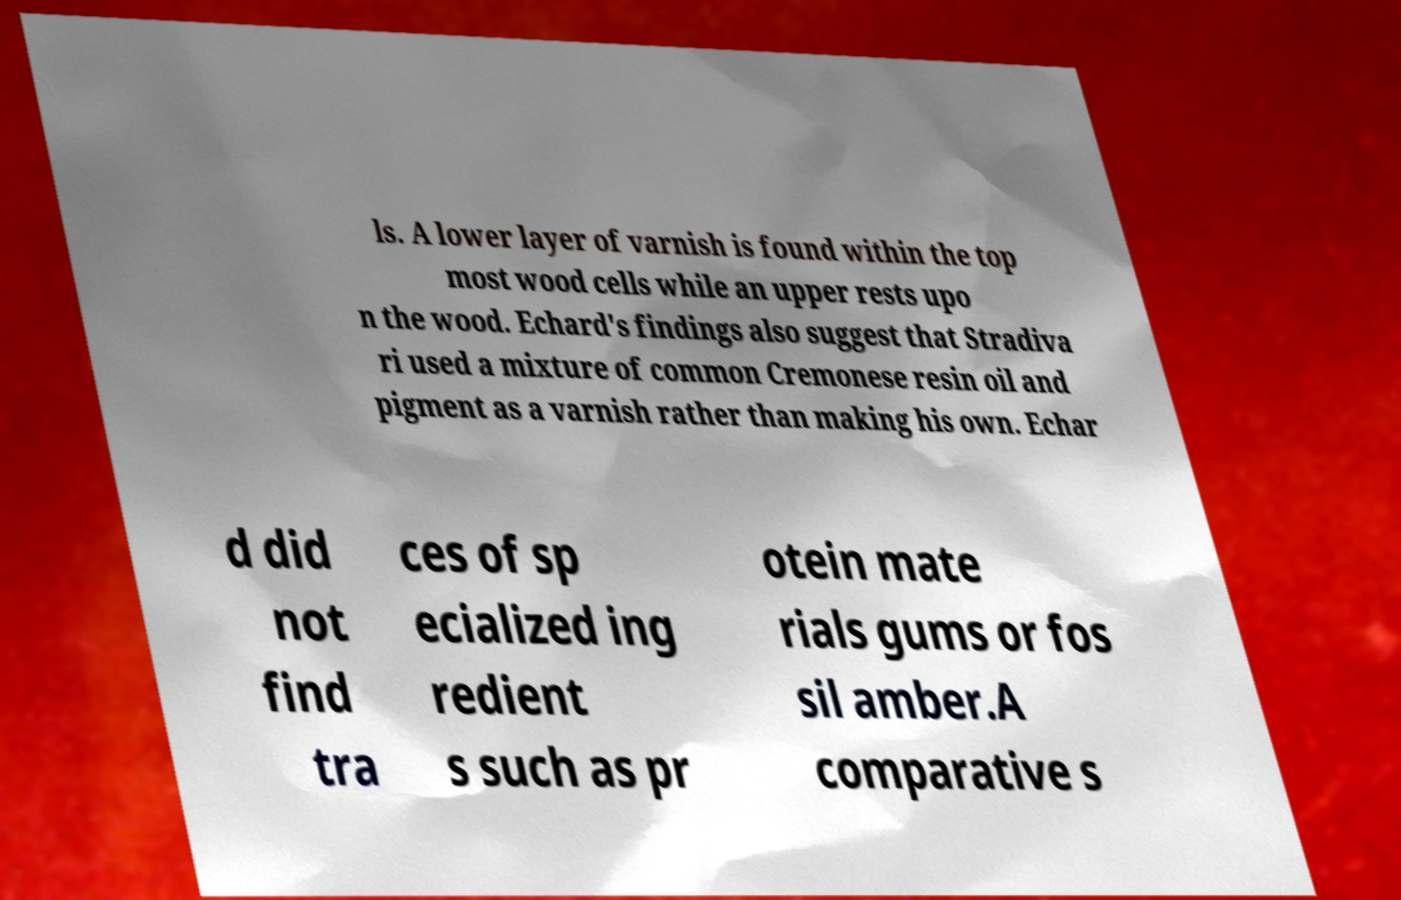Can you read and provide the text displayed in the image?This photo seems to have some interesting text. Can you extract and type it out for me? ls. A lower layer of varnish is found within the top most wood cells while an upper rests upo n the wood. Echard's findings also suggest that Stradiva ri used a mixture of common Cremonese resin oil and pigment as a varnish rather than making his own. Echar d did not find tra ces of sp ecialized ing redient s such as pr otein mate rials gums or fos sil amber.A comparative s 